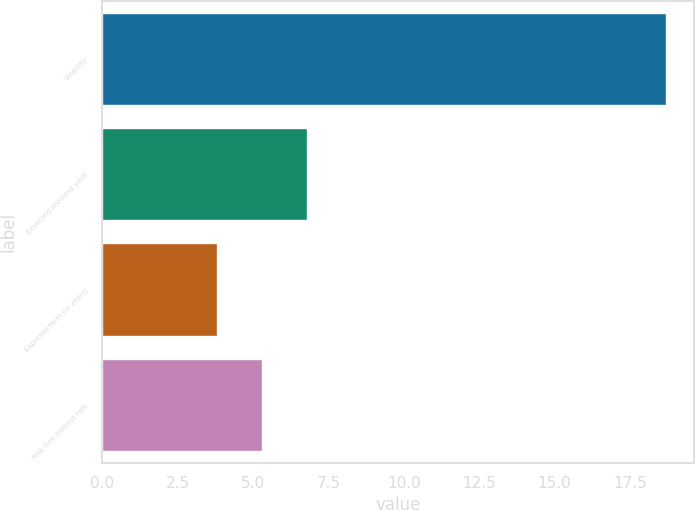Convert chart to OTSL. <chart><loc_0><loc_0><loc_500><loc_500><bar_chart><fcel>Volatility<fcel>Expected dividend yield<fcel>Expected term (in years)<fcel>Risk free interest rate<nl><fcel>18.7<fcel>6.78<fcel>3.8<fcel>5.29<nl></chart> 